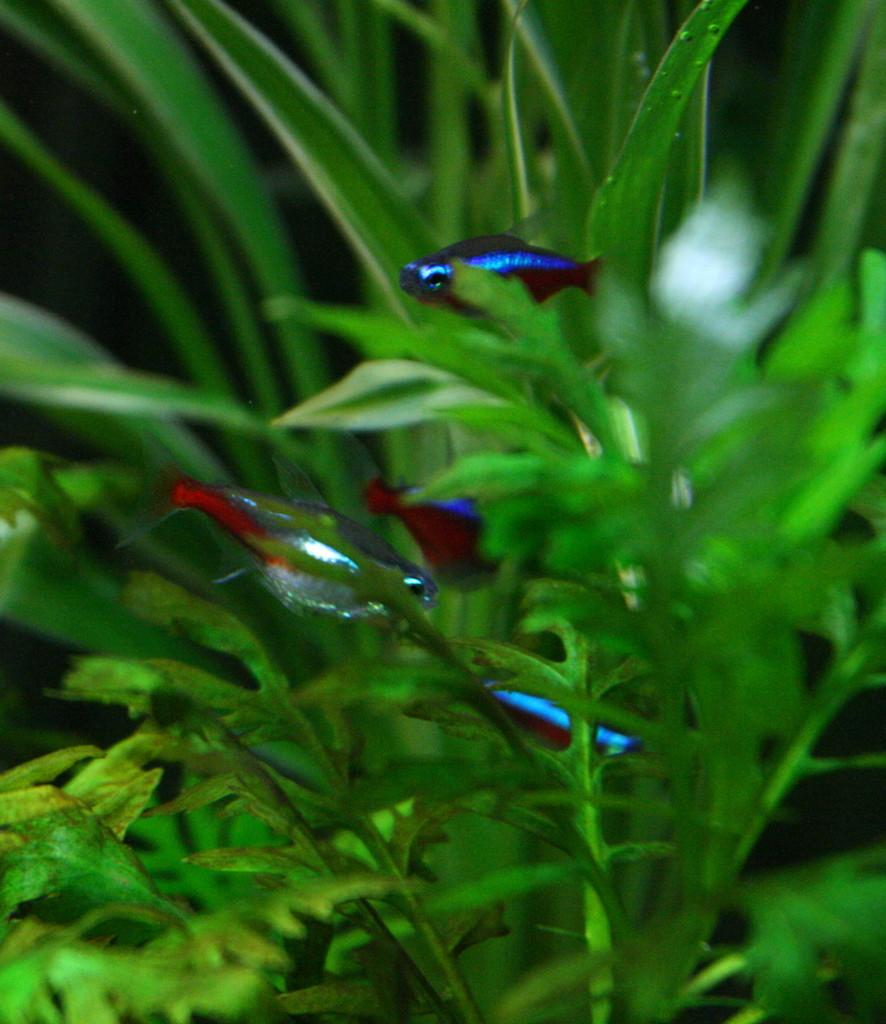What type of animals can be seen in the image? There are fishes in the water. What else can be seen in the image besides the fishes? There are plants visible in the image. How many cents can be seen in the image? There are no cents present in the image. Is there a stranger interacting with the fishes in the image? There is no stranger present in the image. 